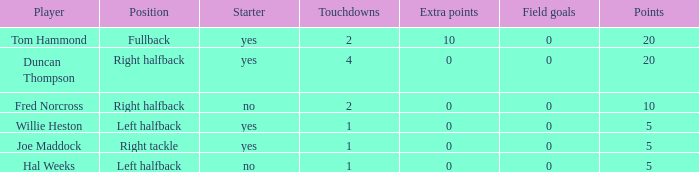How many touchdowns are there when there were 0 extra points and Hal Weeks had left halfback? 1.0. 